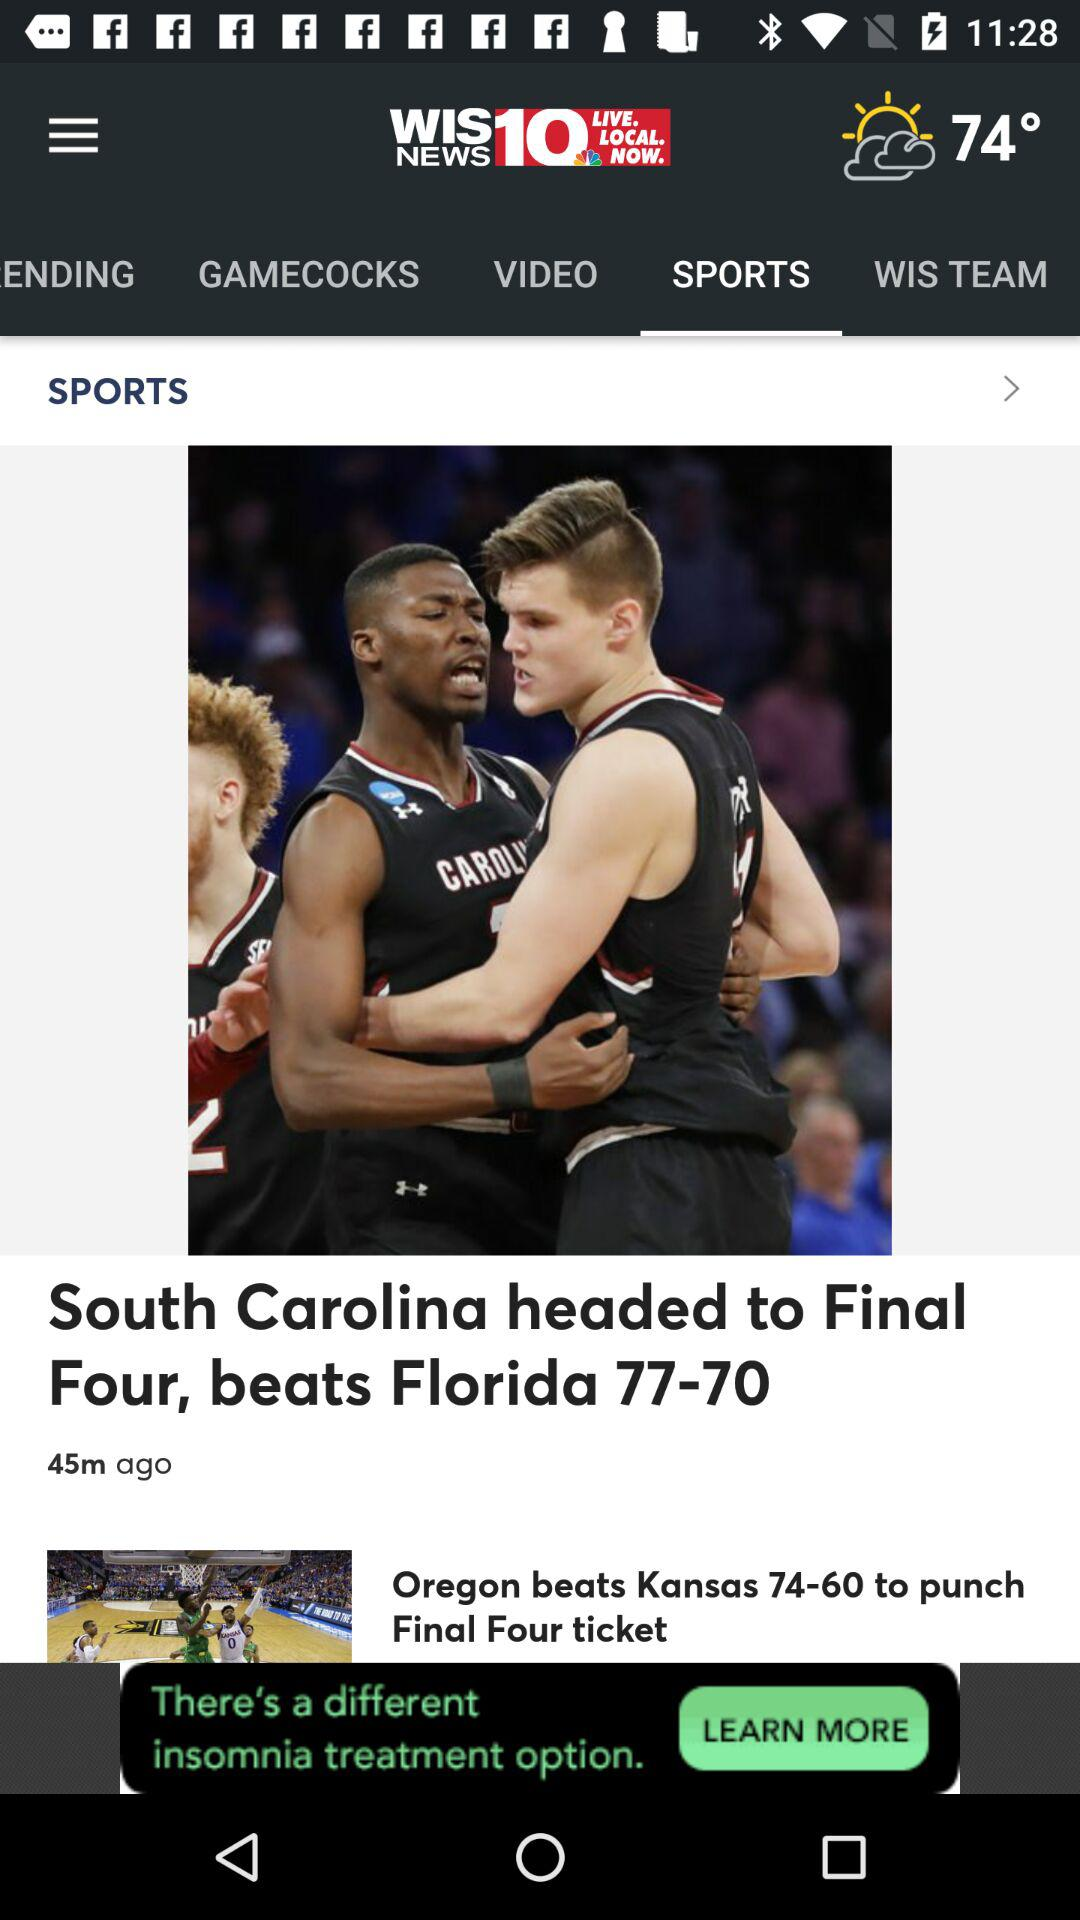When was the news "South Carolina headed to Final Four" posted? The news "South Carolina headed to Final Four" was posted 45 minutes ago. 